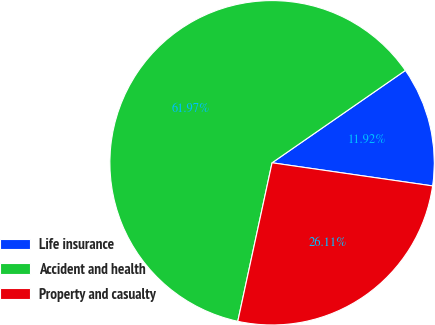<chart> <loc_0><loc_0><loc_500><loc_500><pie_chart><fcel>Life insurance<fcel>Accident and health<fcel>Property and casualty<nl><fcel>11.92%<fcel>61.96%<fcel>26.11%<nl></chart> 